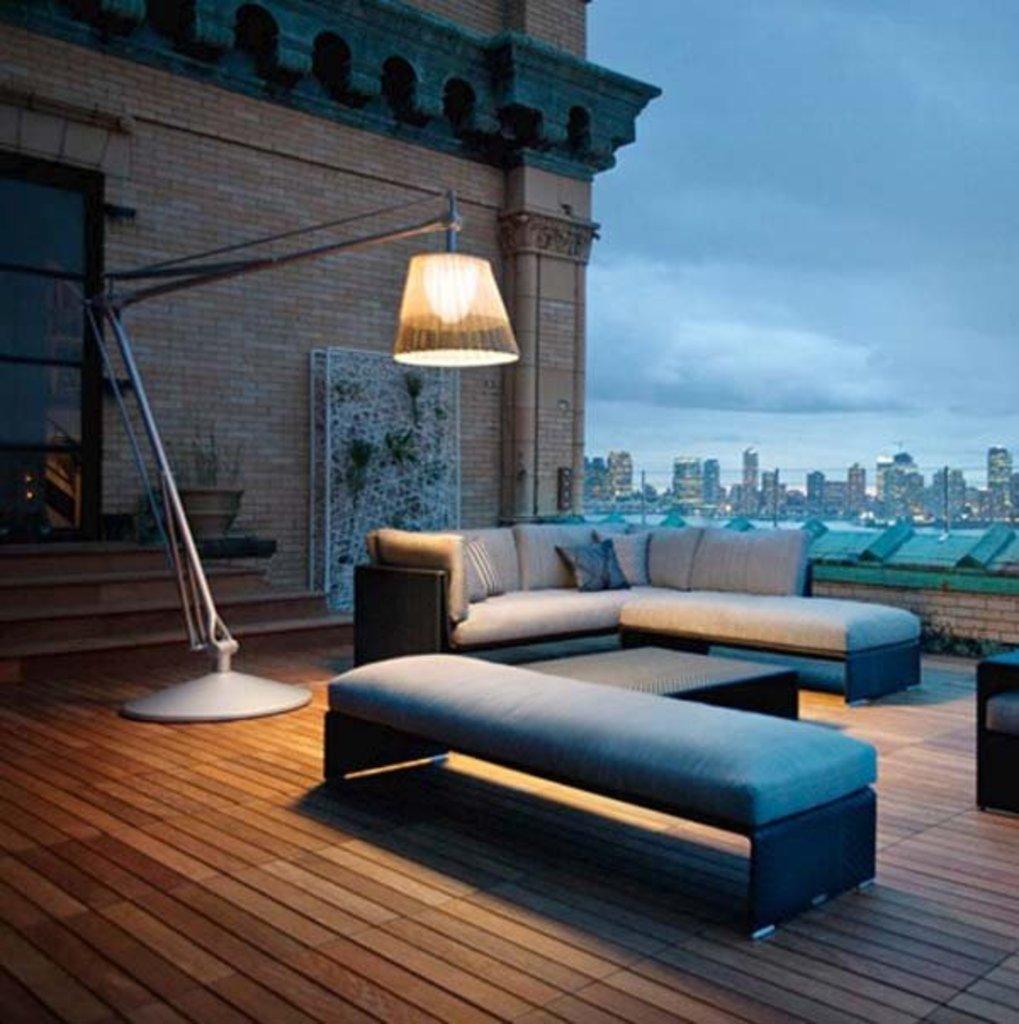Could you give a brief overview of what you see in this image? In this image there is a building, in front of the building there is a lamp, below the lamp there is a sofa set and a table on the wooden surface. In the background there are buildings and the sky. 